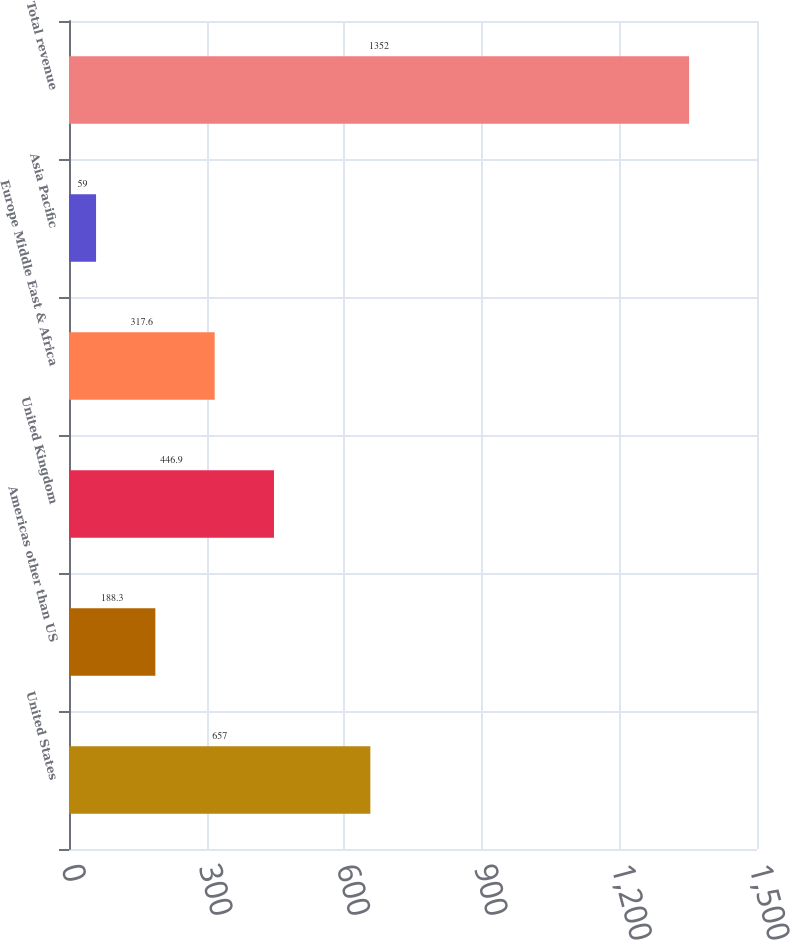Convert chart to OTSL. <chart><loc_0><loc_0><loc_500><loc_500><bar_chart><fcel>United States<fcel>Americas other than US<fcel>United Kingdom<fcel>Europe Middle East & Africa<fcel>Asia Pacific<fcel>Total revenue<nl><fcel>657<fcel>188.3<fcel>446.9<fcel>317.6<fcel>59<fcel>1352<nl></chart> 